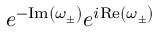<formula> <loc_0><loc_0><loc_500><loc_500>e ^ { - I m \left ( \omega _ { \pm } \right ) } e ^ { i R e \left ( \omega _ { \pm } \right ) }</formula> 